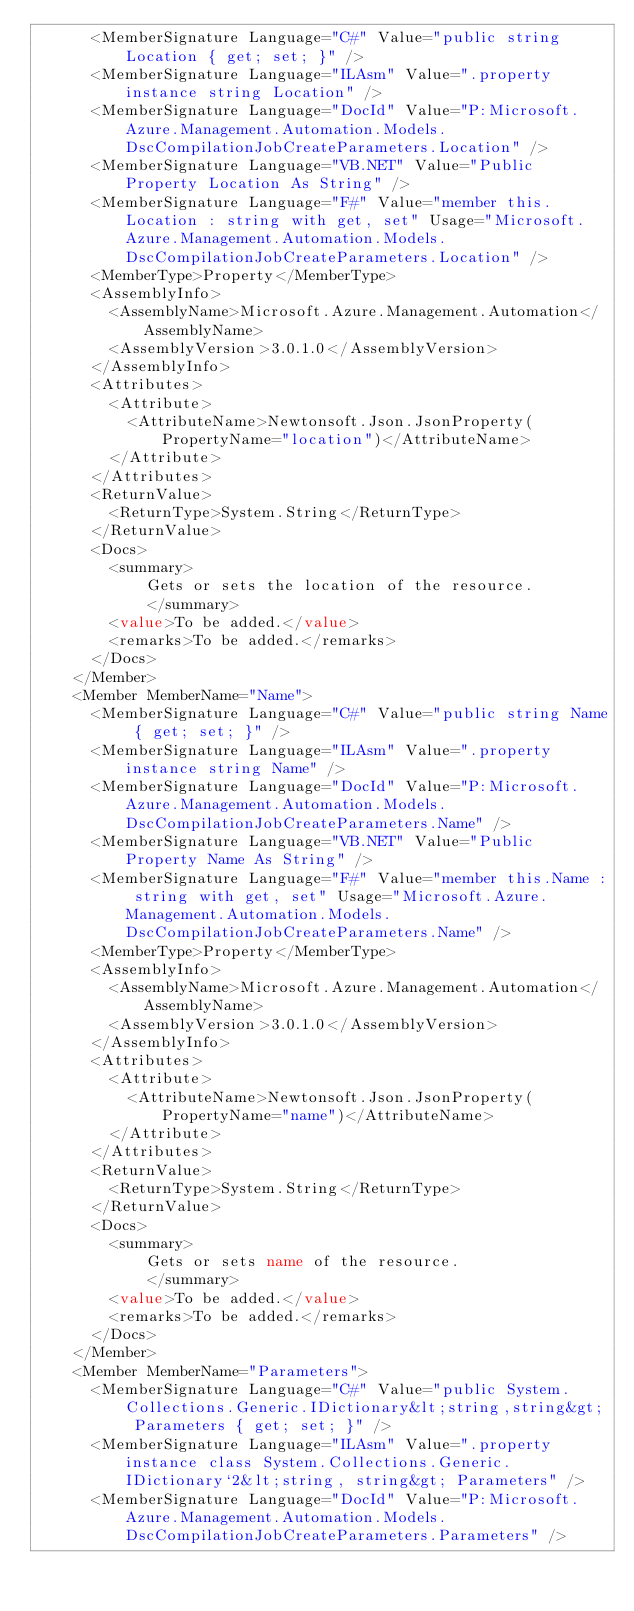<code> <loc_0><loc_0><loc_500><loc_500><_XML_>      <MemberSignature Language="C#" Value="public string Location { get; set; }" />
      <MemberSignature Language="ILAsm" Value=".property instance string Location" />
      <MemberSignature Language="DocId" Value="P:Microsoft.Azure.Management.Automation.Models.DscCompilationJobCreateParameters.Location" />
      <MemberSignature Language="VB.NET" Value="Public Property Location As String" />
      <MemberSignature Language="F#" Value="member this.Location : string with get, set" Usage="Microsoft.Azure.Management.Automation.Models.DscCompilationJobCreateParameters.Location" />
      <MemberType>Property</MemberType>
      <AssemblyInfo>
        <AssemblyName>Microsoft.Azure.Management.Automation</AssemblyName>
        <AssemblyVersion>3.0.1.0</AssemblyVersion>
      </AssemblyInfo>
      <Attributes>
        <Attribute>
          <AttributeName>Newtonsoft.Json.JsonProperty(PropertyName="location")</AttributeName>
        </Attribute>
      </Attributes>
      <ReturnValue>
        <ReturnType>System.String</ReturnType>
      </ReturnValue>
      <Docs>
        <summary>
            Gets or sets the location of the resource.
            </summary>
        <value>To be added.</value>
        <remarks>To be added.</remarks>
      </Docs>
    </Member>
    <Member MemberName="Name">
      <MemberSignature Language="C#" Value="public string Name { get; set; }" />
      <MemberSignature Language="ILAsm" Value=".property instance string Name" />
      <MemberSignature Language="DocId" Value="P:Microsoft.Azure.Management.Automation.Models.DscCompilationJobCreateParameters.Name" />
      <MemberSignature Language="VB.NET" Value="Public Property Name As String" />
      <MemberSignature Language="F#" Value="member this.Name : string with get, set" Usage="Microsoft.Azure.Management.Automation.Models.DscCompilationJobCreateParameters.Name" />
      <MemberType>Property</MemberType>
      <AssemblyInfo>
        <AssemblyName>Microsoft.Azure.Management.Automation</AssemblyName>
        <AssemblyVersion>3.0.1.0</AssemblyVersion>
      </AssemblyInfo>
      <Attributes>
        <Attribute>
          <AttributeName>Newtonsoft.Json.JsonProperty(PropertyName="name")</AttributeName>
        </Attribute>
      </Attributes>
      <ReturnValue>
        <ReturnType>System.String</ReturnType>
      </ReturnValue>
      <Docs>
        <summary>
            Gets or sets name of the resource.
            </summary>
        <value>To be added.</value>
        <remarks>To be added.</remarks>
      </Docs>
    </Member>
    <Member MemberName="Parameters">
      <MemberSignature Language="C#" Value="public System.Collections.Generic.IDictionary&lt;string,string&gt; Parameters { get; set; }" />
      <MemberSignature Language="ILAsm" Value=".property instance class System.Collections.Generic.IDictionary`2&lt;string, string&gt; Parameters" />
      <MemberSignature Language="DocId" Value="P:Microsoft.Azure.Management.Automation.Models.DscCompilationJobCreateParameters.Parameters" /></code> 